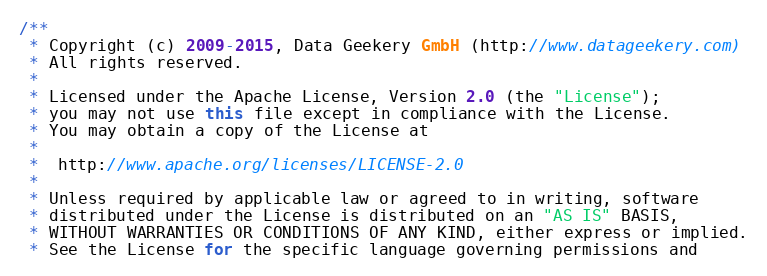<code> <loc_0><loc_0><loc_500><loc_500><_Java_>/**
 * Copyright (c) 2009-2015, Data Geekery GmbH (http://www.datageekery.com)
 * All rights reserved.
 *
 * Licensed under the Apache License, Version 2.0 (the "License");
 * you may not use this file except in compliance with the License.
 * You may obtain a copy of the License at
 *
 *  http://www.apache.org/licenses/LICENSE-2.0
 *
 * Unless required by applicable law or agreed to in writing, software
 * distributed under the License is distributed on an "AS IS" BASIS,
 * WITHOUT WARRANTIES OR CONDITIONS OF ANY KIND, either express or implied.
 * See the License for the specific language governing permissions and</code> 